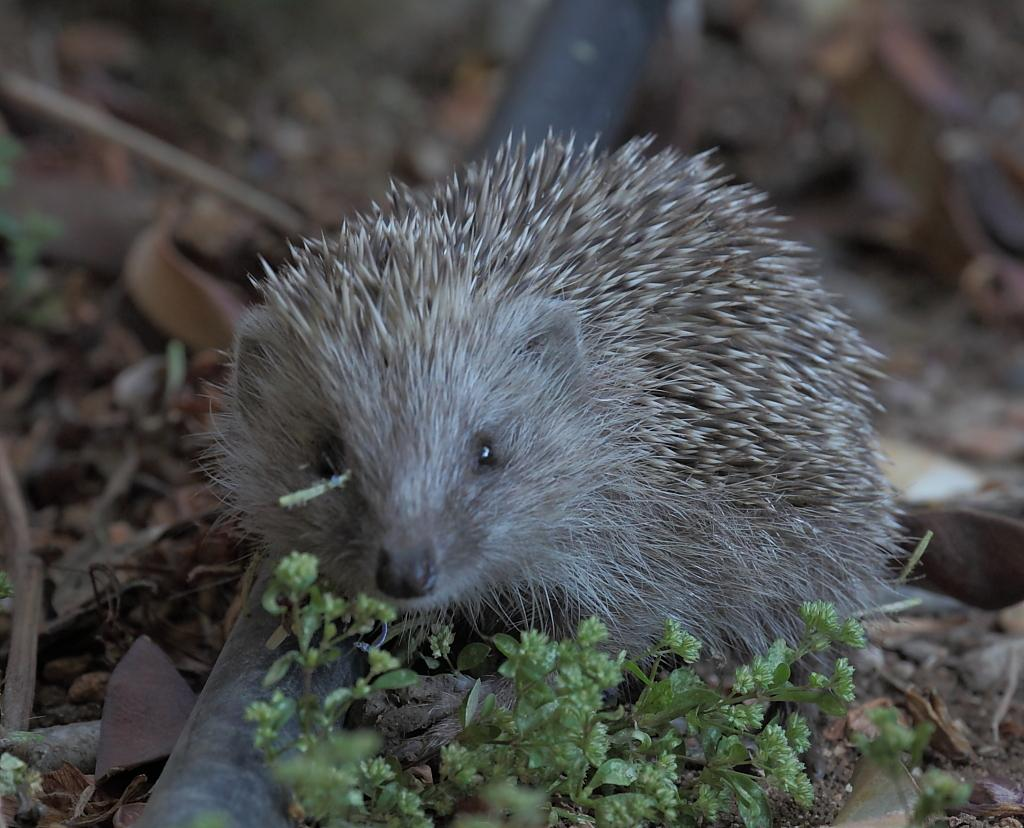What animal is present in the image? There is a hedgehog in the image. What is the hedgehog resting on? The hedgehog is on an object. What type of vegetation can be seen at the bottom of the image? There are tiny plants at the bottom of the image. What else can be seen at the bottom of the image besides the plants? There are other objects at the bottom of the image. How would you describe the background of the image? The background of the image is blurred. What type of spacecraft can be seen in the image? There is no spacecraft present in the image; it features a hedgehog on an object with tiny plants and other objects at the bottom. How many men are visible in the image? There are no men present in the image. 